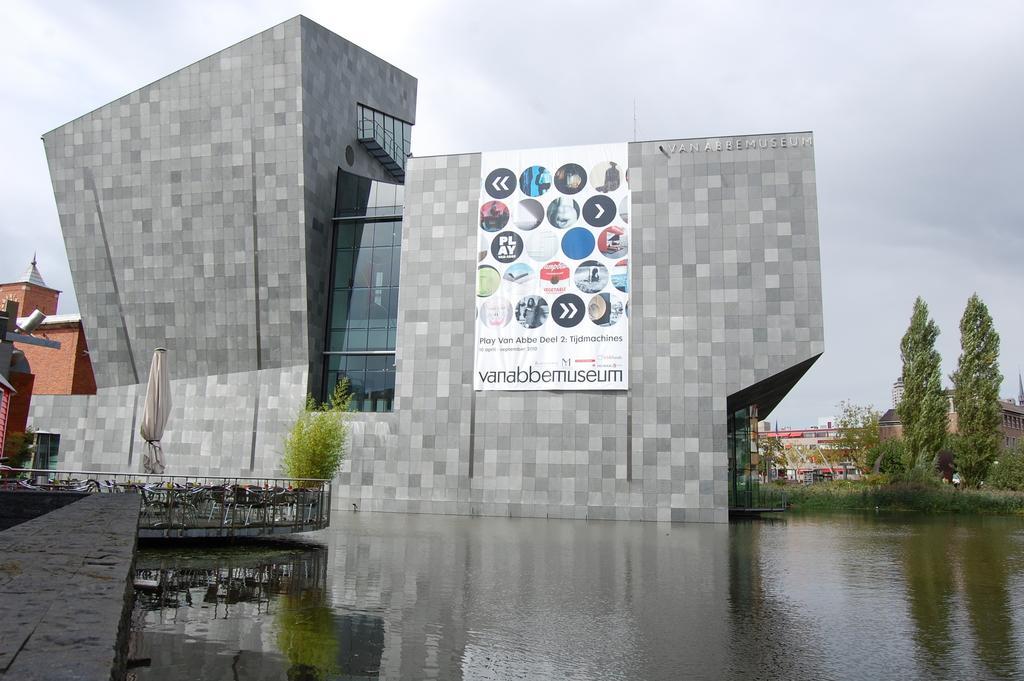Describe this image in one or two sentences. There is a water pond, near a building, on which, there is a banner. And the building is having glass windows. On the left side, there is a floor, there are chairs arranged on the floor near a plant. In the background, there are buildings, there are trees and there is sky. 